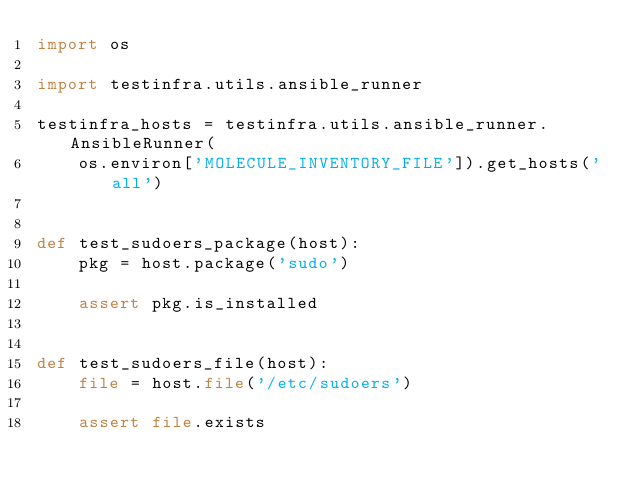<code> <loc_0><loc_0><loc_500><loc_500><_Python_>import os

import testinfra.utils.ansible_runner

testinfra_hosts = testinfra.utils.ansible_runner.AnsibleRunner(
    os.environ['MOLECULE_INVENTORY_FILE']).get_hosts('all')


def test_sudoers_package(host):
    pkg = host.package('sudo')

    assert pkg.is_installed


def test_sudoers_file(host):
    file = host.file('/etc/sudoers')

    assert file.exists
</code> 